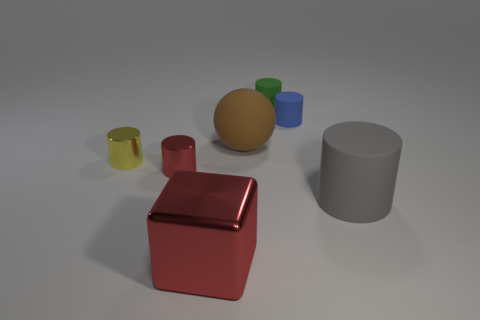Is there anything else that has the same shape as the yellow metallic thing?
Your answer should be compact. Yes. Are there any blue rubber objects?
Your response must be concise. Yes. Is the number of big purple blocks less than the number of large gray matte cylinders?
Give a very brief answer. Yes. What number of big red spheres are made of the same material as the red cylinder?
Offer a terse response. 0. There is another big thing that is made of the same material as the big brown object; what is its color?
Give a very brief answer. Gray. There is a tiny blue thing; what shape is it?
Provide a succinct answer. Cylinder. How many cylinders have the same color as the block?
Offer a very short reply. 1. The gray rubber thing that is the same size as the brown matte object is what shape?
Your answer should be compact. Cylinder. Is there a blue cylinder that has the same size as the blue rubber thing?
Provide a succinct answer. No. There is a gray thing that is the same size as the block; what is it made of?
Keep it short and to the point. Rubber. 